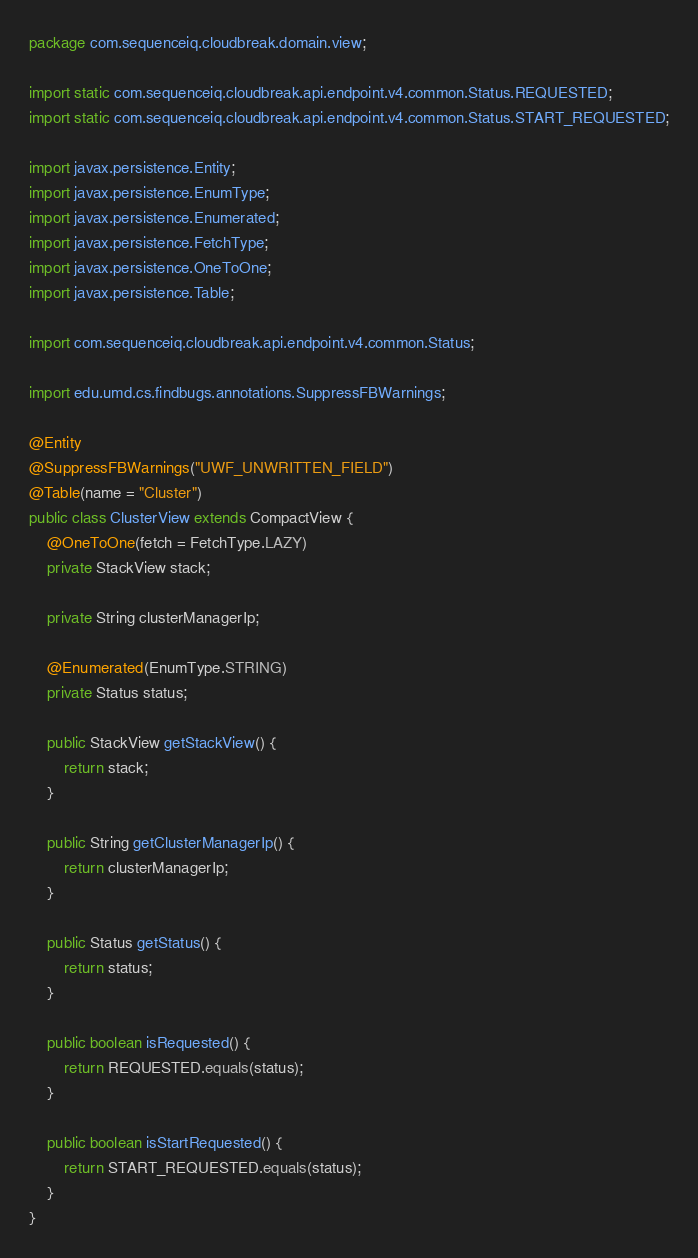Convert code to text. <code><loc_0><loc_0><loc_500><loc_500><_Java_>package com.sequenceiq.cloudbreak.domain.view;

import static com.sequenceiq.cloudbreak.api.endpoint.v4.common.Status.REQUESTED;
import static com.sequenceiq.cloudbreak.api.endpoint.v4.common.Status.START_REQUESTED;

import javax.persistence.Entity;
import javax.persistence.EnumType;
import javax.persistence.Enumerated;
import javax.persistence.FetchType;
import javax.persistence.OneToOne;
import javax.persistence.Table;

import com.sequenceiq.cloudbreak.api.endpoint.v4.common.Status;

import edu.umd.cs.findbugs.annotations.SuppressFBWarnings;

@Entity
@SuppressFBWarnings("UWF_UNWRITTEN_FIELD")
@Table(name = "Cluster")
public class ClusterView extends CompactView {
    @OneToOne(fetch = FetchType.LAZY)
    private StackView stack;

    private String clusterManagerIp;

    @Enumerated(EnumType.STRING)
    private Status status;

    public StackView getStackView() {
        return stack;
    }

    public String getClusterManagerIp() {
        return clusterManagerIp;
    }

    public Status getStatus() {
        return status;
    }

    public boolean isRequested() {
        return REQUESTED.equals(status);
    }

    public boolean isStartRequested() {
        return START_REQUESTED.equals(status);
    }
}
</code> 